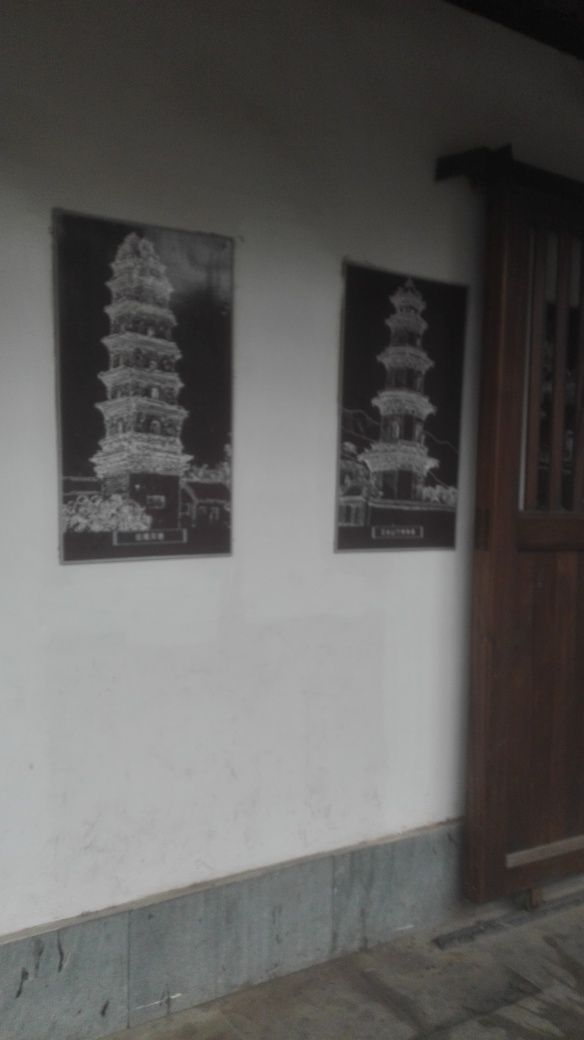What are the objects displayed in the image? The image showcases two framed pictures of pagoda-style towers, which are architectural structures often found in East Asian temple complexes. These depict intricate designs and multiple tiers, which are characteristics of traditional pagoda construction. 